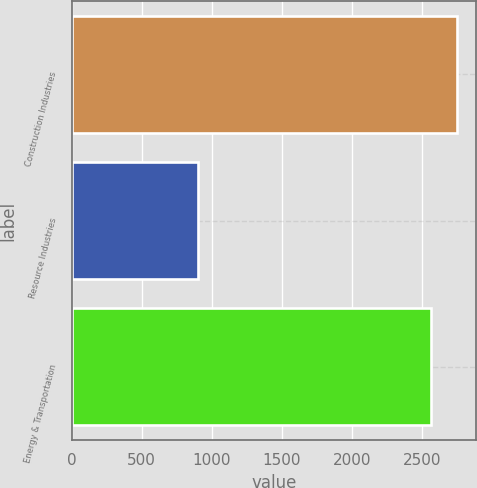Convert chart. <chart><loc_0><loc_0><loc_500><loc_500><bar_chart><fcel>Construction Industries<fcel>Resource Industries<fcel>Energy & Transportation<nl><fcel>2753.3<fcel>906<fcel>2569<nl></chart> 